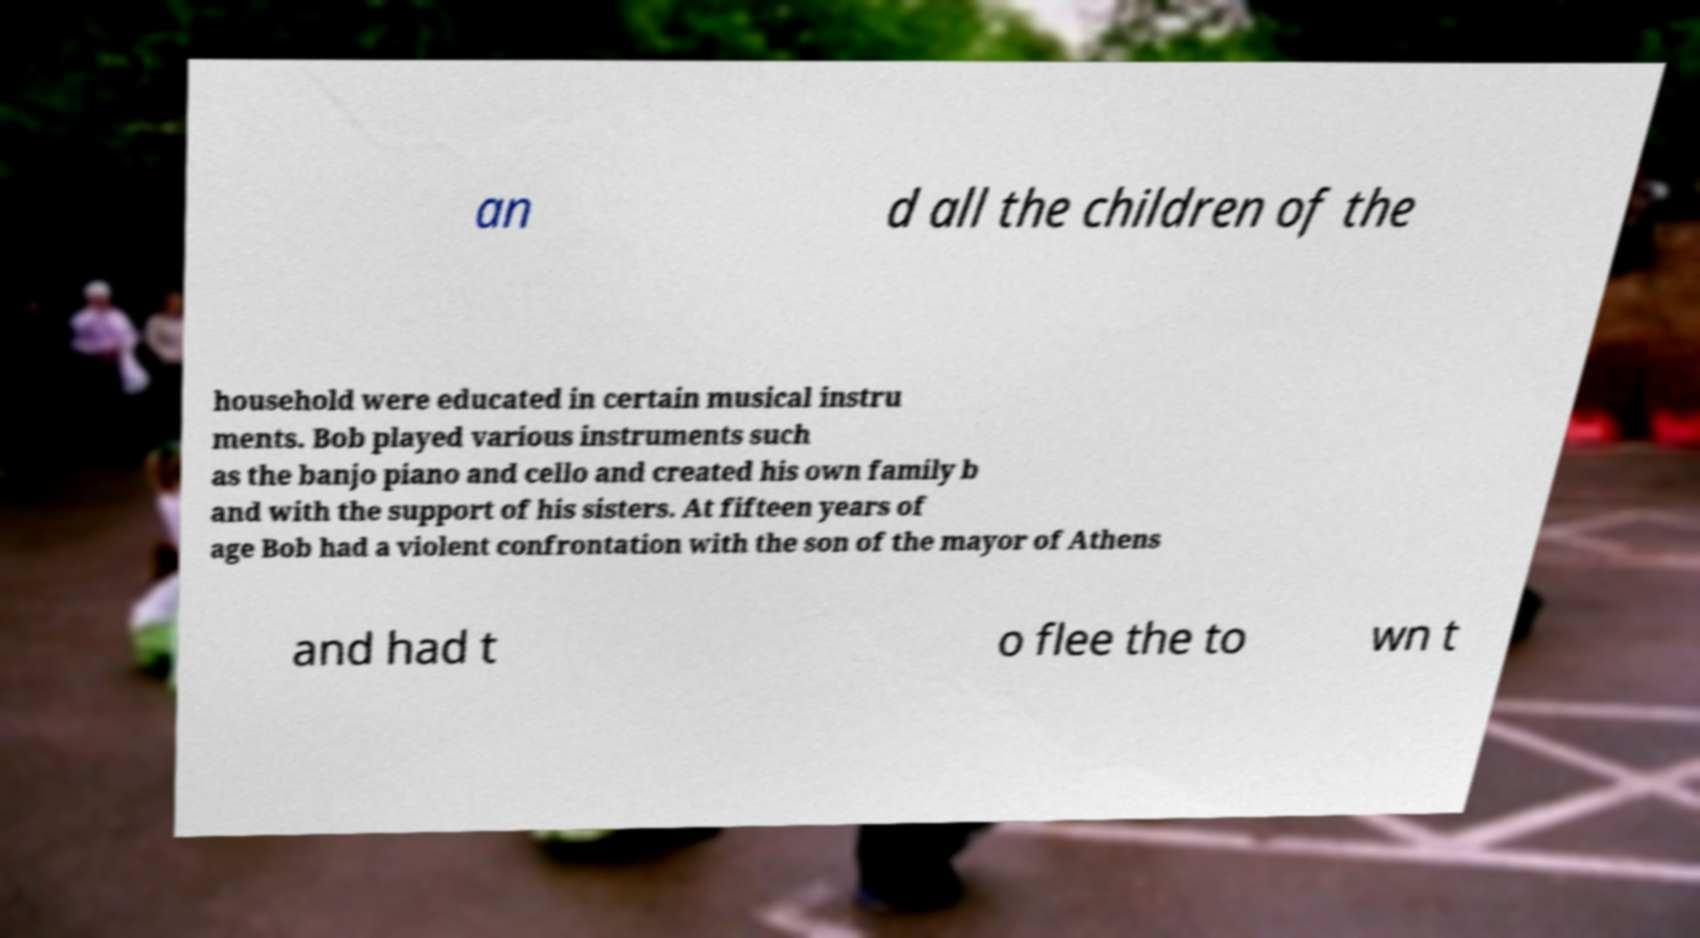Can you accurately transcribe the text from the provided image for me? an d all the children of the household were educated in certain musical instru ments. Bob played various instruments such as the banjo piano and cello and created his own family b and with the support of his sisters. At fifteen years of age Bob had a violent confrontation with the son of the mayor of Athens and had t o flee the to wn t 